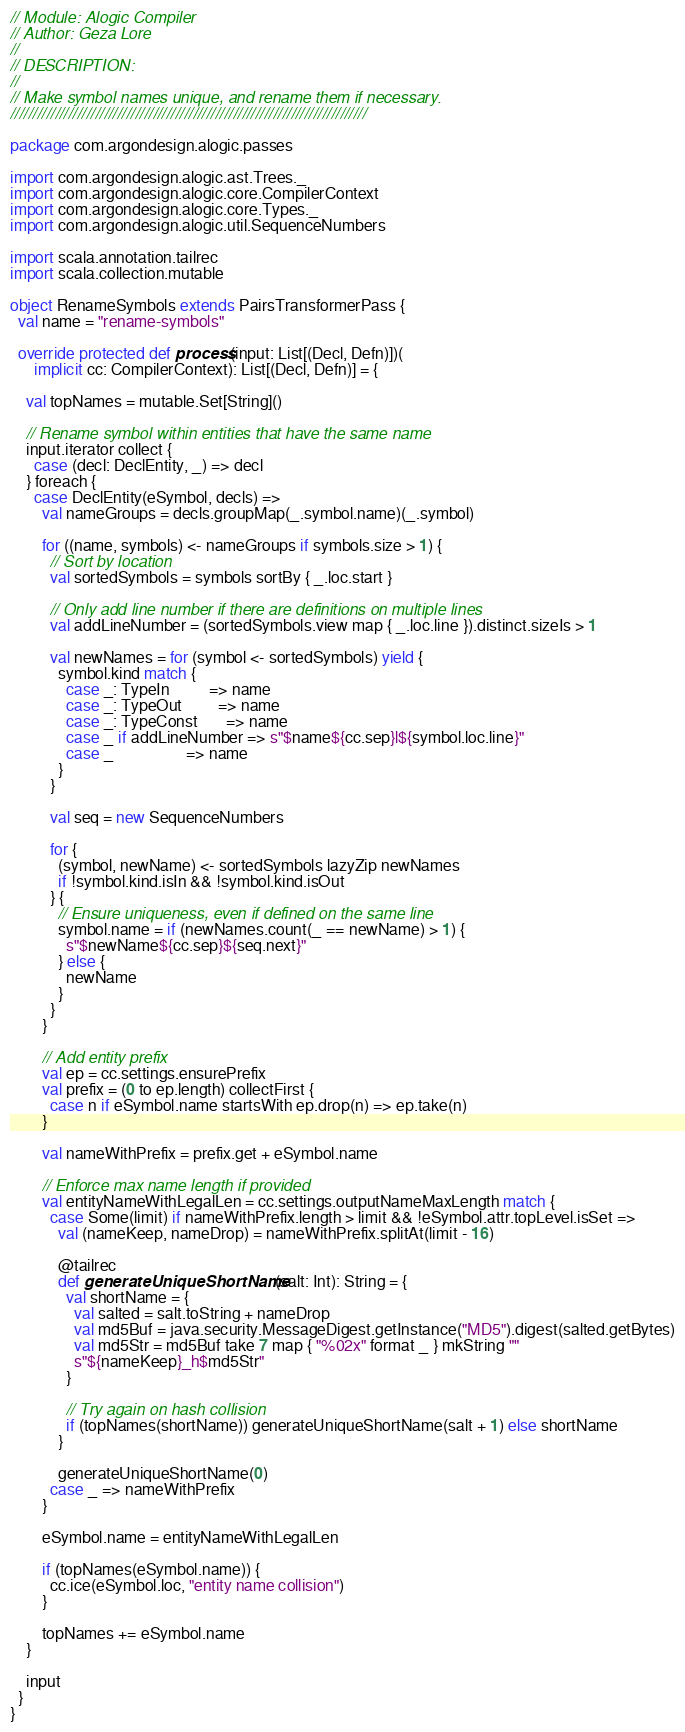Convert code to text. <code><loc_0><loc_0><loc_500><loc_500><_Scala_>// Module: Alogic Compiler
// Author: Geza Lore
//
// DESCRIPTION:
//
// Make symbol names unique, and rename them if necessary.
////////////////////////////////////////////////////////////////////////////////

package com.argondesign.alogic.passes

import com.argondesign.alogic.ast.Trees._
import com.argondesign.alogic.core.CompilerContext
import com.argondesign.alogic.core.Types._
import com.argondesign.alogic.util.SequenceNumbers

import scala.annotation.tailrec
import scala.collection.mutable

object RenameSymbols extends PairsTransformerPass {
  val name = "rename-symbols"

  override protected def process(input: List[(Decl, Defn)])(
      implicit cc: CompilerContext): List[(Decl, Defn)] = {

    val topNames = mutable.Set[String]()

    // Rename symbol within entities that have the same name
    input.iterator collect {
      case (decl: DeclEntity, _) => decl
    } foreach {
      case DeclEntity(eSymbol, decls) =>
        val nameGroups = decls.groupMap(_.symbol.name)(_.symbol)

        for ((name, symbols) <- nameGroups if symbols.size > 1) {
          // Sort by location
          val sortedSymbols = symbols sortBy { _.loc.start }

          // Only add line number if there are definitions on multiple lines
          val addLineNumber = (sortedSymbols.view map { _.loc.line }).distinct.sizeIs > 1

          val newNames = for (symbol <- sortedSymbols) yield {
            symbol.kind match {
              case _: TypeIn          => name
              case _: TypeOut         => name
              case _: TypeConst       => name
              case _ if addLineNumber => s"$name${cc.sep}l${symbol.loc.line}"
              case _                  => name
            }
          }

          val seq = new SequenceNumbers

          for {
            (symbol, newName) <- sortedSymbols lazyZip newNames
            if !symbol.kind.isIn && !symbol.kind.isOut
          } {
            // Ensure uniqueness, even if defined on the same line
            symbol.name = if (newNames.count(_ == newName) > 1) {
              s"$newName${cc.sep}${seq.next}"
            } else {
              newName
            }
          }
        }

        // Add entity prefix
        val ep = cc.settings.ensurePrefix
        val prefix = (0 to ep.length) collectFirst {
          case n if eSymbol.name startsWith ep.drop(n) => ep.take(n)
        }

        val nameWithPrefix = prefix.get + eSymbol.name

        // Enforce max name length if provided
        val entityNameWithLegalLen = cc.settings.outputNameMaxLength match {
          case Some(limit) if nameWithPrefix.length > limit && !eSymbol.attr.topLevel.isSet =>
            val (nameKeep, nameDrop) = nameWithPrefix.splitAt(limit - 16)

            @tailrec
            def generateUniqueShortName(salt: Int): String = {
              val shortName = {
                val salted = salt.toString + nameDrop
                val md5Buf = java.security.MessageDigest.getInstance("MD5").digest(salted.getBytes)
                val md5Str = md5Buf take 7 map { "%02x" format _ } mkString ""
                s"${nameKeep}_h$md5Str"
              }

              // Try again on hash collision
              if (topNames(shortName)) generateUniqueShortName(salt + 1) else shortName
            }

            generateUniqueShortName(0)
          case _ => nameWithPrefix
        }

        eSymbol.name = entityNameWithLegalLen

        if (topNames(eSymbol.name)) {
          cc.ice(eSymbol.loc, "entity name collision")
        }

        topNames += eSymbol.name
    }

    input
  }
}
</code> 